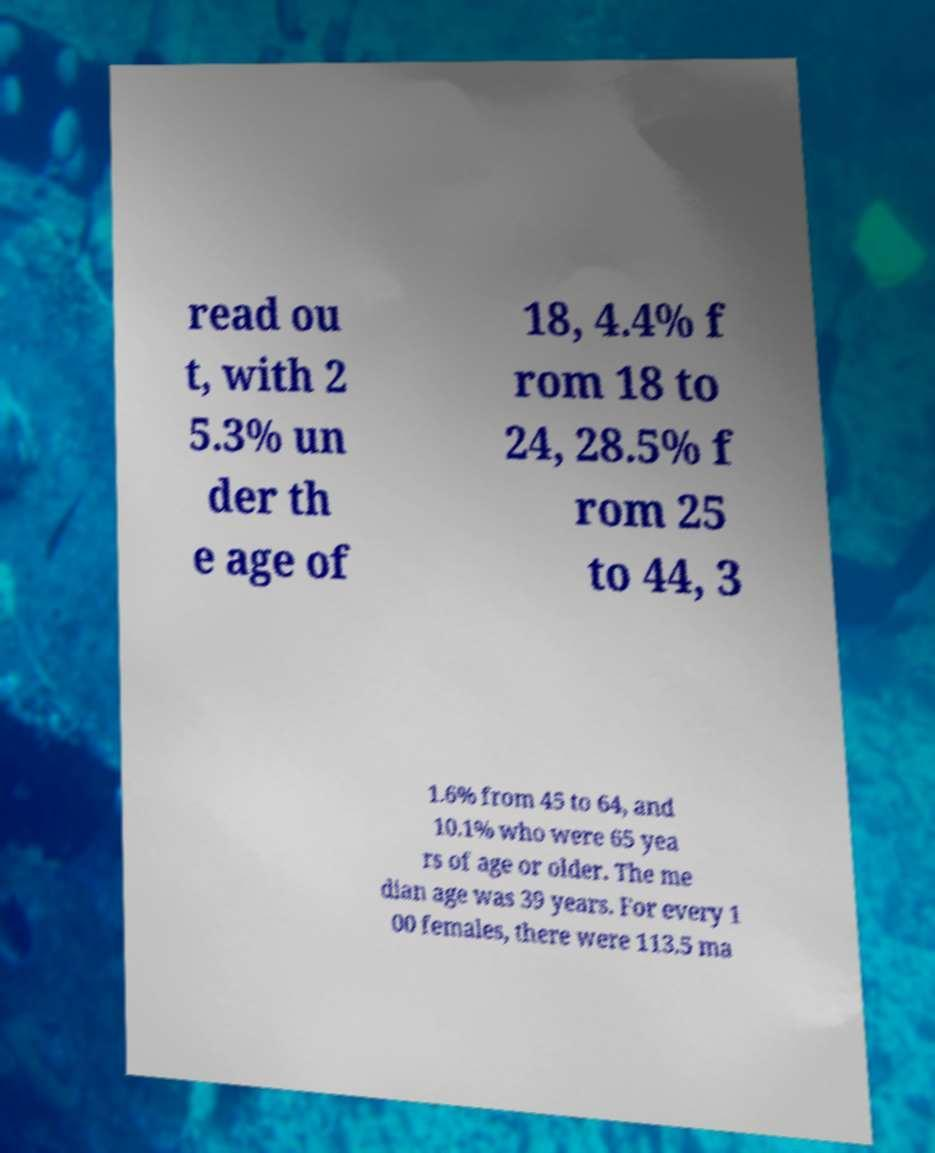There's text embedded in this image that I need extracted. Can you transcribe it verbatim? read ou t, with 2 5.3% un der th e age of 18, 4.4% f rom 18 to 24, 28.5% f rom 25 to 44, 3 1.6% from 45 to 64, and 10.1% who were 65 yea rs of age or older. The me dian age was 39 years. For every 1 00 females, there were 113.5 ma 